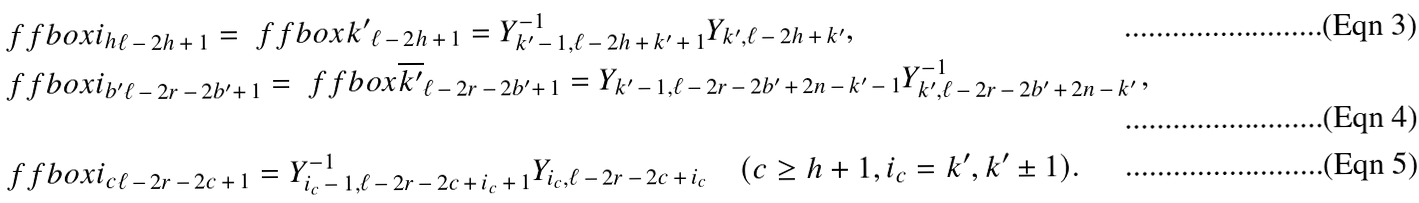<formula> <loc_0><loc_0><loc_500><loc_500>& \ f f b o x { i _ { h } } _ { \ell \, - \, 2 h \, + \, 1 } = \ f f b o x { k ^ { \prime } } _ { \ell \, - \, 2 h \, + \, 1 } = Y ^ { - 1 } _ { k ^ { \prime } \, - \, 1 , \ell \, - \, 2 h \, + \, k ^ { \prime } \, + \, 1 } Y _ { k ^ { \prime } , \ell \, - \, 2 h \, + \, k ^ { \prime } } , \\ & \ f f b o x { i _ { b ^ { \prime } } } _ { \ell \, - \, 2 r \, - \, 2 b ^ { \prime } + \, 1 } = \ f f b o x { \overline { k ^ { \prime } } } _ { \ell \, - \, 2 r \, - \, 2 b ^ { \prime } + \, 1 } = Y _ { k ^ { \prime } \, - \, 1 , \ell \, - \, 2 r \, - \, 2 b ^ { \prime } \, + \, 2 n \, - \, k ^ { \prime } \, - \, 1 } Y ^ { - 1 } _ { k ^ { \prime } , \ell \, - \, 2 r \, - \, 2 b ^ { \prime } \, + \, 2 n \, - \, k ^ { \prime } \, } , \\ & \ f f b o x { i _ { c } } _ { \ell \, - \, 2 r \, - \, 2 c \, + \, 1 } = Y ^ { - 1 } _ { i _ { c } \, - \, 1 , \ell \, - \, 2 r \, - \, 2 c \, + \, i _ { c } \, + \, 1 } Y _ { i _ { c } , \ell \, - \, 2 r \, - \, 2 c \, + \, i _ { c } } \quad ( c \geq h + 1 , i _ { c } = k ^ { \prime } , k ^ { \prime } \pm 1 ) .</formula> 